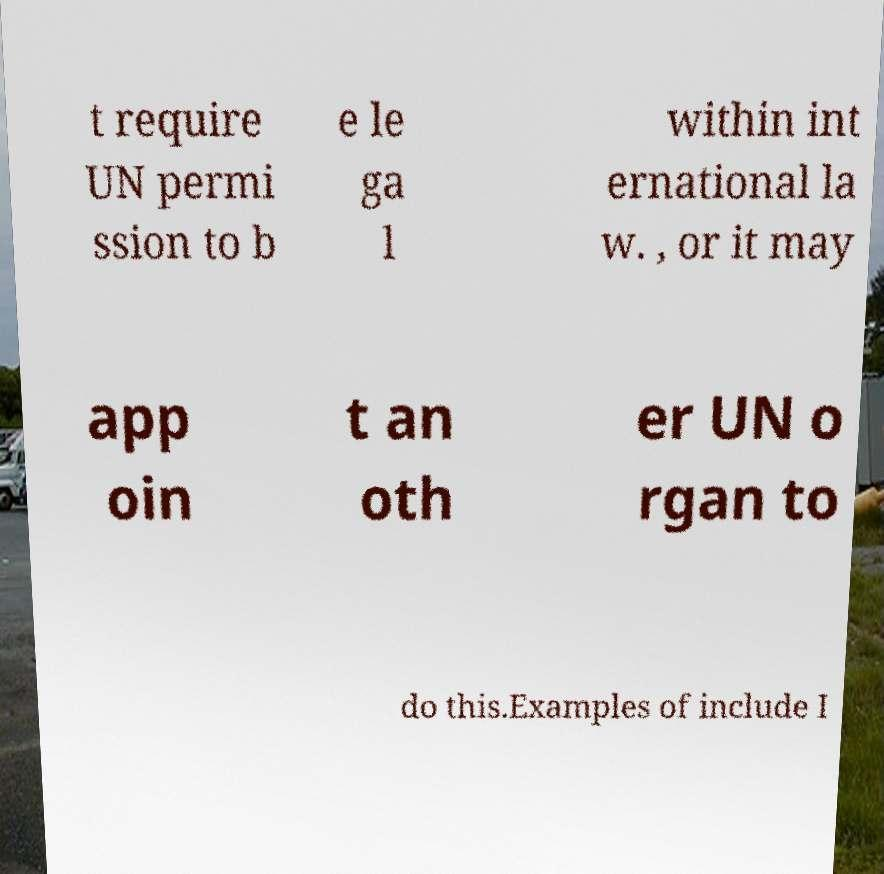I need the written content from this picture converted into text. Can you do that? t require UN permi ssion to b e le ga l within int ernational la w. , or it may app oin t an oth er UN o rgan to do this.Examples of include I 